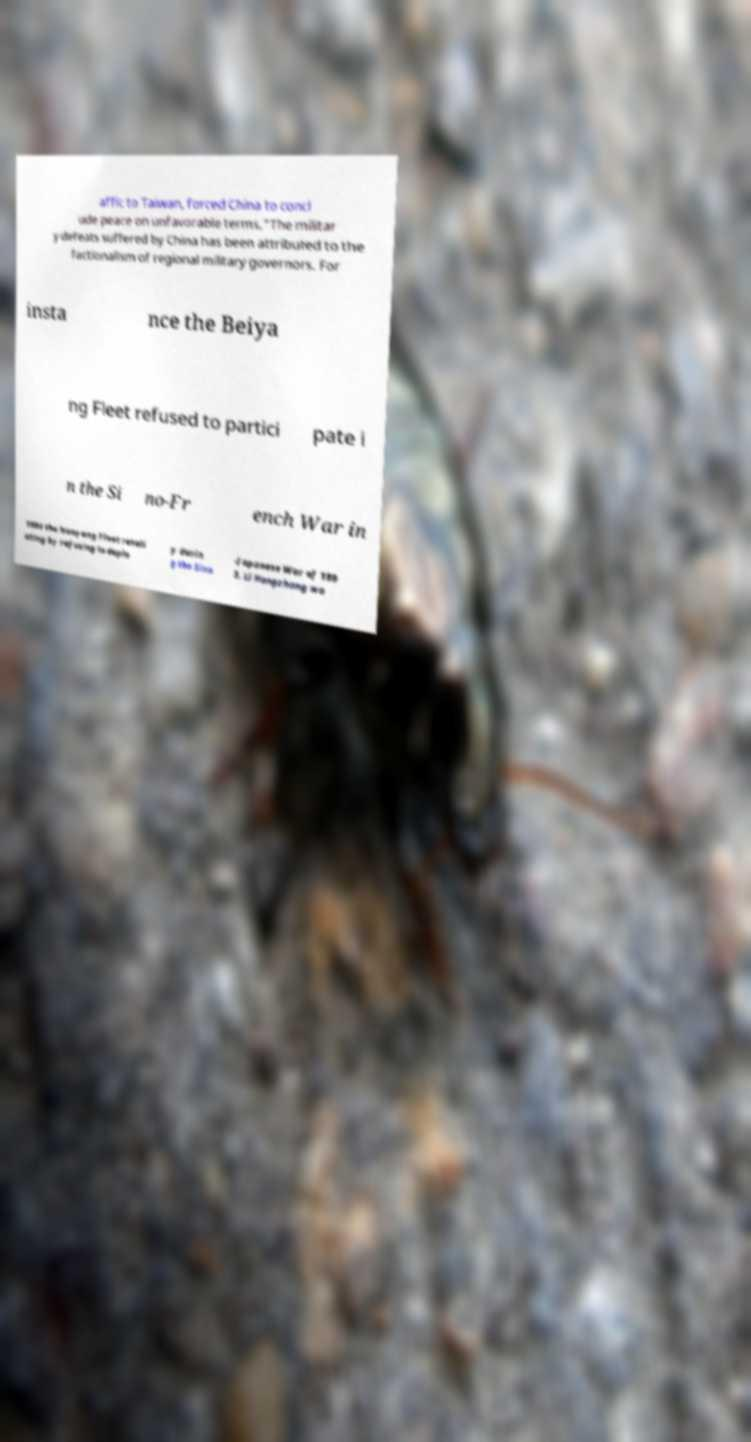Can you accurately transcribe the text from the provided image for me? affic to Taiwan, forced China to concl ude peace on unfavorable terms."The militar y defeats suffered by China has been attributed to the factionalism of regional military governors. For insta nce the Beiya ng Fleet refused to partici pate i n the Si no-Fr ench War in 1884 the Nanyang Fleet retali ating by refusing to deplo y durin g the Sino -Japanese War of 189 5. Li Hongzhang wa 